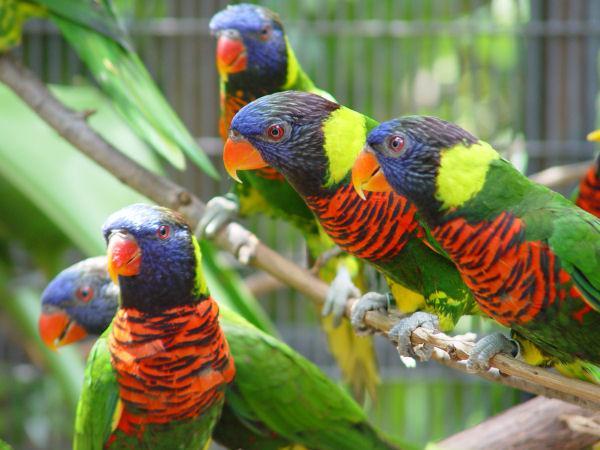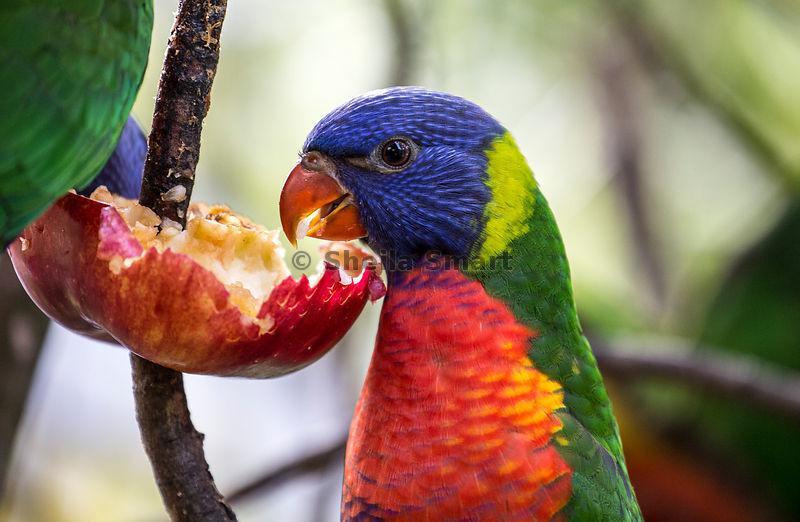The first image is the image on the left, the second image is the image on the right. Evaluate the accuracy of this statement regarding the images: "In both image the rainbow lorikeet is eating.". Is it true? Answer yes or no. No. The first image is the image on the left, the second image is the image on the right. Analyze the images presented: Is the assertion "There are at least four birds in total." valid? Answer yes or no. Yes. 